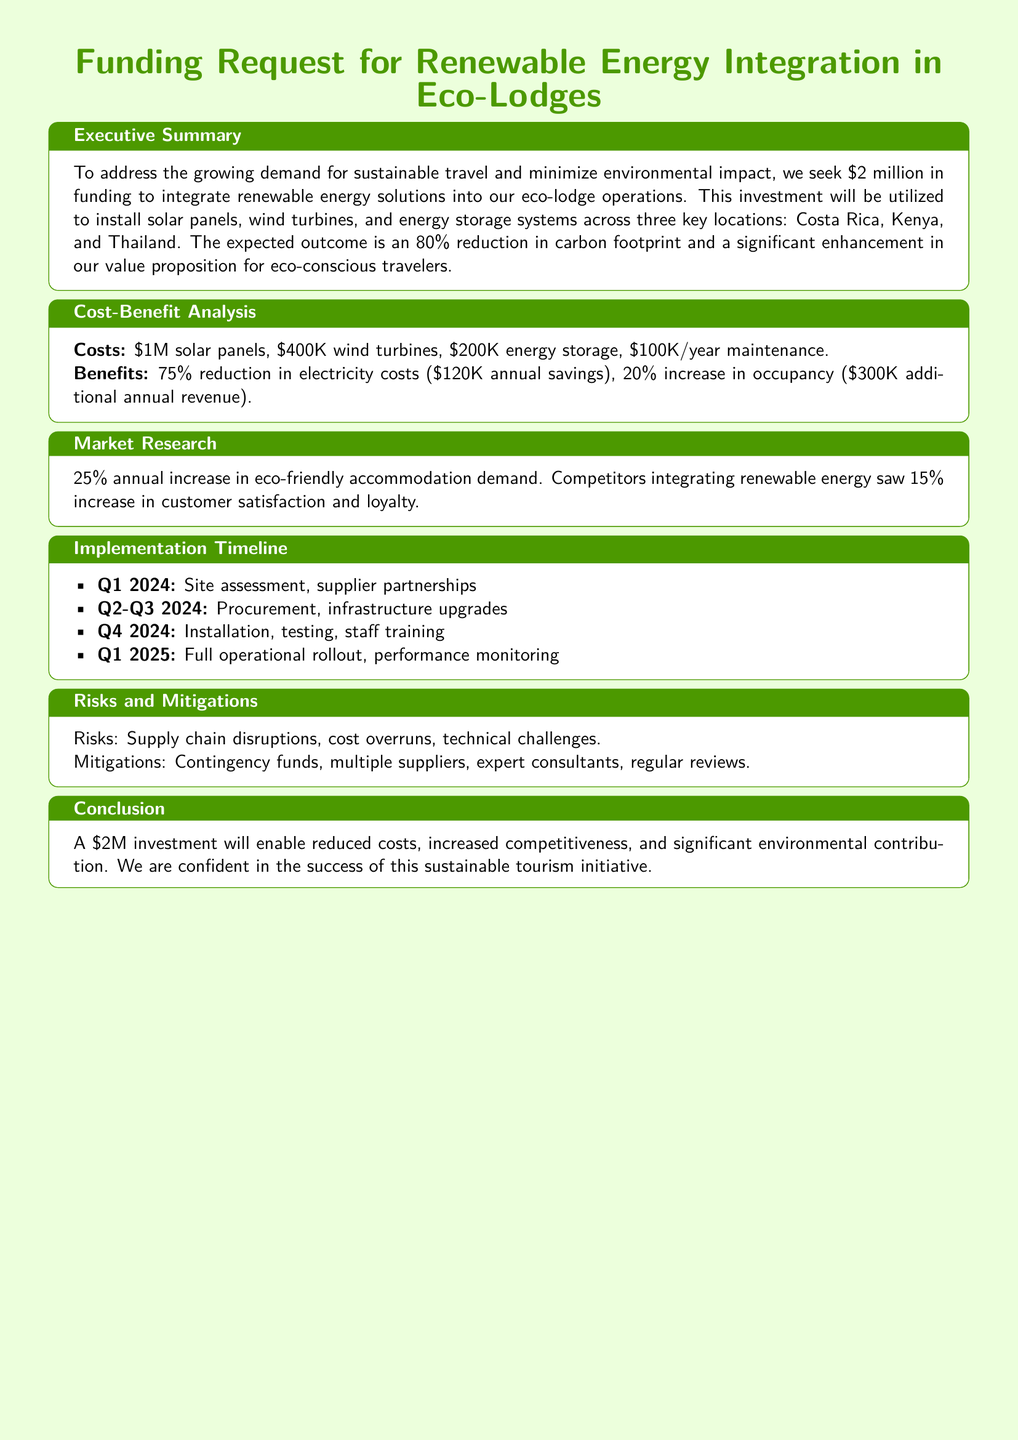What is the total funding requested? The total funding requested is explicitly stated in the executive summary of the document.
Answer: $2 million What is the expected reduction in carbon footprint? The expected outcome regarding carbon footprint is mentioned in the executive summary, indicating the percentage reduction aimed for.
Answer: 80% What percentage increase in occupancy is anticipated? The percentage increase in occupancy is found in the cost-benefit analysis section, detailing the expected growth through renewable integration.
Answer: 20% What are the total maintenance costs per year? The annual maintenance costs are specified in the cost-benefit analysis and can be calculated directly.
Answer: $100K/year What is the first step in the implementation timeline? The implementation timeline lists various steps, with the first step occurring in Q1 2024.
Answer: Site assessment What are the main types of renewable energy to be integrated? The executive summary mentions specific renewable energy solutions to be integrated at the eco-lodges.
Answer: Solar panels, wind turbines, energy storage What is the total cost for solar panels? The document specifies the cost for solar panels in the cost-benefit analysis section.
Answer: $1M What risks are identified in the project? The risks section outlines potential challenges that might affect the project, categorized accordingly.
Answer: Supply chain disruptions What is the estimated annual savings from electricity cost reduction? The cost-benefit analysis directly provides the annual savings figure from reduced electricity costs due to the renewable energy integration.
Answer: $120K 